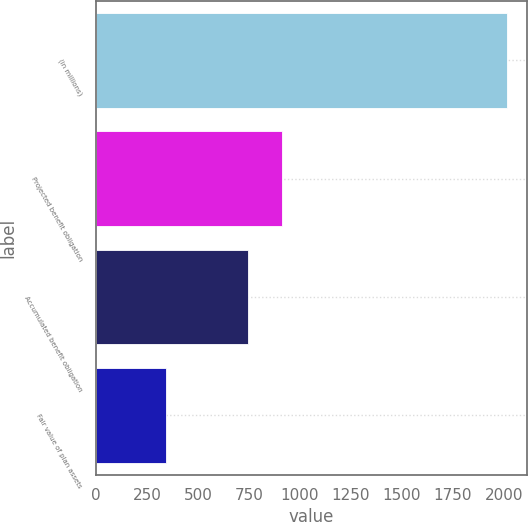Convert chart to OTSL. <chart><loc_0><loc_0><loc_500><loc_500><bar_chart><fcel>(in millions)<fcel>Projected benefit obligation<fcel>Accumulated benefit obligation<fcel>Fair value of plan assets<nl><fcel>2014<fcel>913.2<fcel>746<fcel>342<nl></chart> 